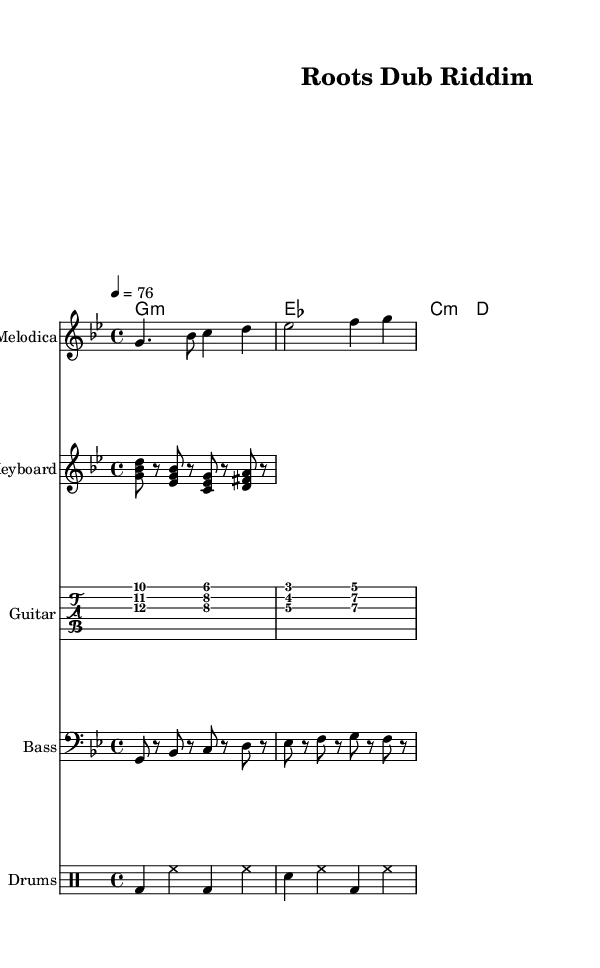What is the key signature of this music? The key signature is G minor, which is indicated by two flats (B♭ and E♭).
Answer: G minor What is the time signature used in the piece? The time signature is 4/4, denoting four beats per measure with the quarter note getting one beat.
Answer: 4/4 What is the tempo marking of the music? The tempo marking indicates a speed of 76 beats per minute, represented as "4 = 76".
Answer: 76 How many measures are there in the bass line? By counting the bar lines, there are four measures in the bass line section.
Answer: Four What chord is primarily used in the guitar skank during the first two measures? The first two measures in the guitar skank show a G minor chord.
Answer: G minor What rhythmic pattern is utilized in the drum section? The drum section features a pattern incorporating bass drum (bd), snare (sn), and hi-hat (hh) played consistently across the measures.
Answer: Bass and snare pattern Which instrument plays the melodic line in the sheet music? The melodic line is played by the melodica, indicated at the top of the respective staff labeled as "Melodica."
Answer: Melodica 